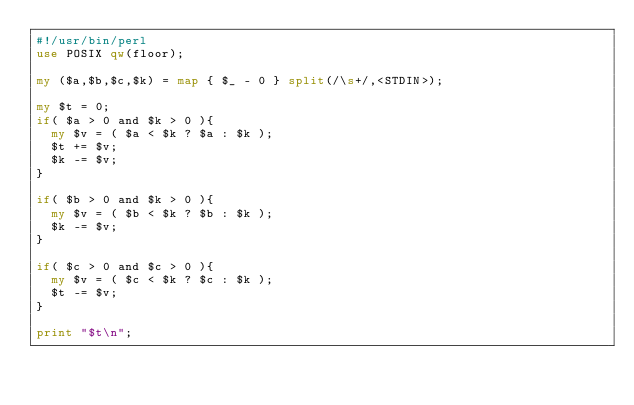<code> <loc_0><loc_0><loc_500><loc_500><_Perl_>#!/usr/bin/perl
use POSIX qw(floor);

my ($a,$b,$c,$k) = map { $_ - 0 } split(/\s+/,<STDIN>);

my $t = 0;
if( $a > 0 and $k > 0 ){
  my $v = ( $a < $k ? $a : $k );
  $t += $v;
  $k -= $v;
}

if( $b > 0 and $k > 0 ){
  my $v = ( $b < $k ? $b : $k );
  $k -= $v;
}

if( $c > 0 and $c > 0 ){
  my $v = ( $c < $k ? $c : $k );
  $t -= $v;
}

print "$t\n";



</code> 